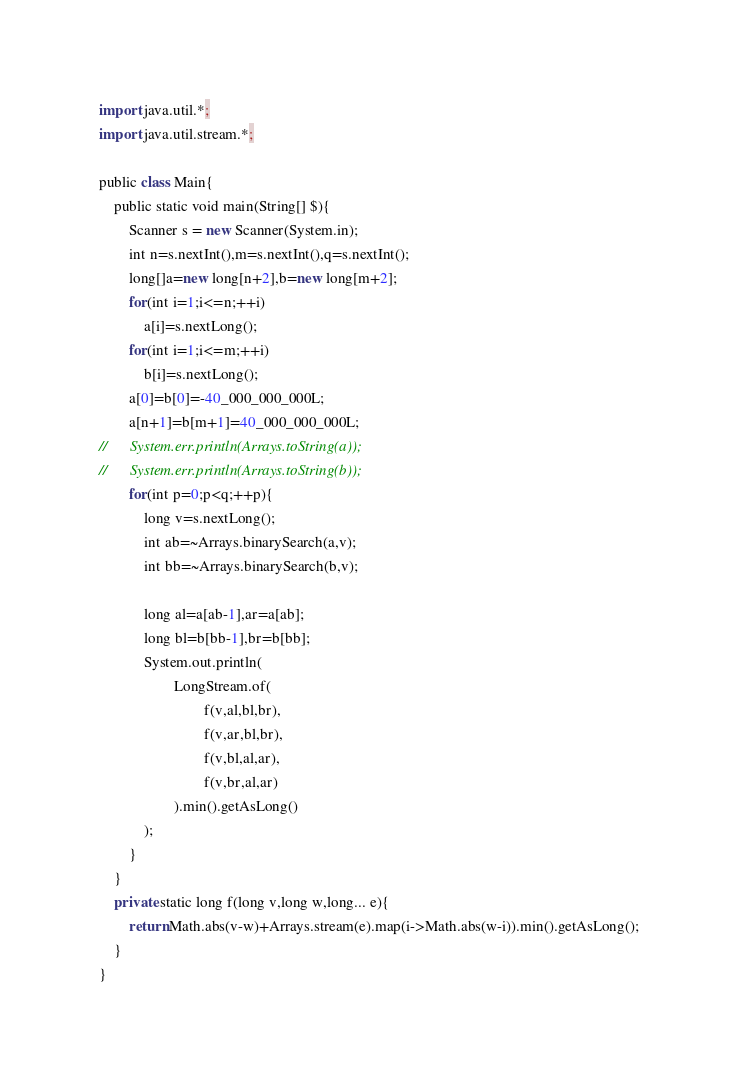Convert code to text. <code><loc_0><loc_0><loc_500><loc_500><_Scala_>import java.util.*;
import java.util.stream.*;

public class Main{
	public static void main(String[] $){
		Scanner s = new Scanner(System.in);
		int n=s.nextInt(),m=s.nextInt(),q=s.nextInt();
		long[]a=new long[n+2],b=new long[m+2];
		for(int i=1;i<=n;++i)
			a[i]=s.nextLong();
		for(int i=1;i<=m;++i)
			b[i]=s.nextLong();
		a[0]=b[0]=-40_000_000_000L;
		a[n+1]=b[m+1]=40_000_000_000L;
//		System.err.println(Arrays.toString(a));
//		System.err.println(Arrays.toString(b));
		for(int p=0;p<q;++p){
			long v=s.nextLong();
			int ab=~Arrays.binarySearch(a,v);
			int bb=~Arrays.binarySearch(b,v);

			long al=a[ab-1],ar=a[ab];
			long bl=b[bb-1],br=b[bb];
			System.out.println(
					LongStream.of(
							f(v,al,bl,br),
							f(v,ar,bl,br),
							f(v,bl,al,ar),
							f(v,br,al,ar)
					).min().getAsLong()
			);
		}
	}
	private static long f(long v,long w,long... e){
		return Math.abs(v-w)+Arrays.stream(e).map(i->Math.abs(w-i)).min().getAsLong();
	}
}</code> 